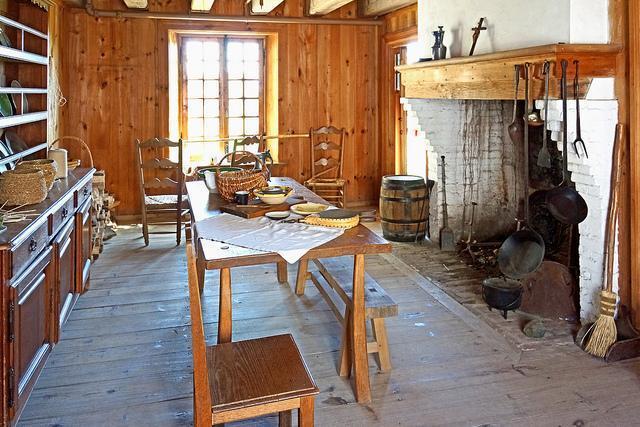How many chairs are in this room?
Give a very brief answer. 3. How many chairs are in the picture?
Give a very brief answer. 3. 